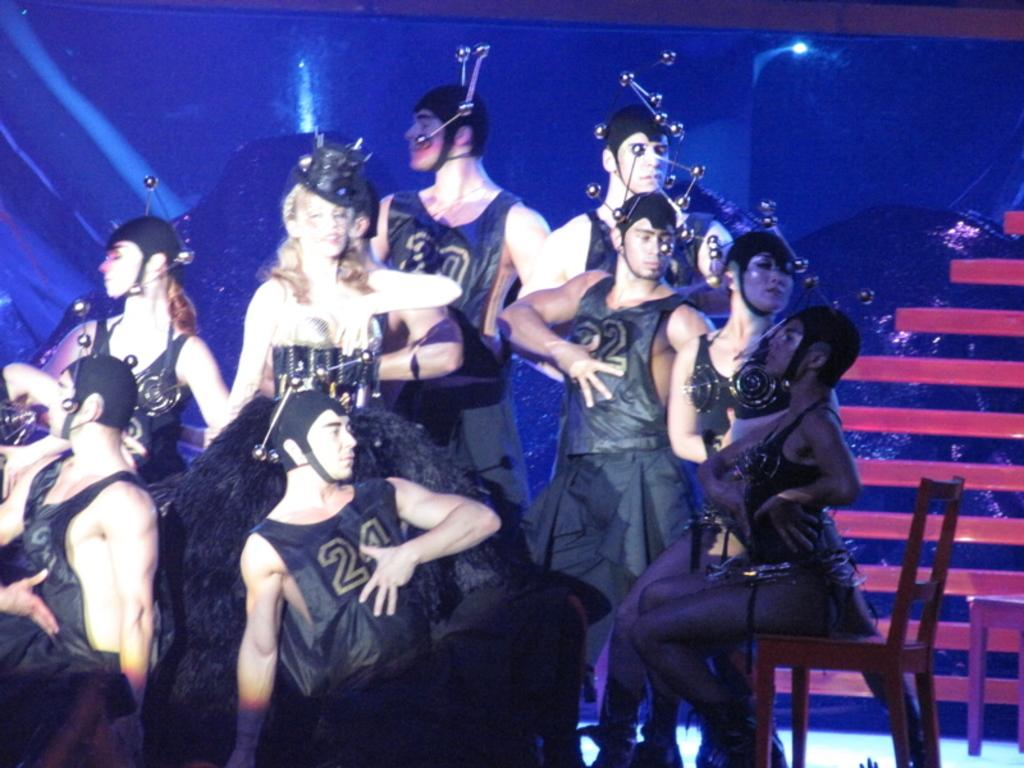How many people are in the image? There are many people in the image. What are the people wearing? The people are wearing the same costume. Can you describe the position of one person in the image? There is a person sitting on a chair in the image. What can be seen behind the people in the image? There is a blue background with lights in the image. What type of meal is being served in the image? There is no meal present in the image; it features a group of people wearing the same costume. What kind of structure can be seen in the background of the image? There is no structure visible in the background of the image; it features a blue background with lights. 